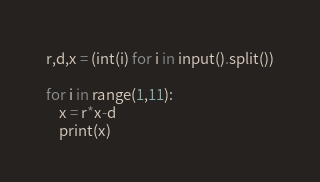Convert code to text. <code><loc_0><loc_0><loc_500><loc_500><_Python_>r,d,x = (int(i) for i in input().split())

for i in range(1,11):
    x = r*x-d
    print(x)</code> 